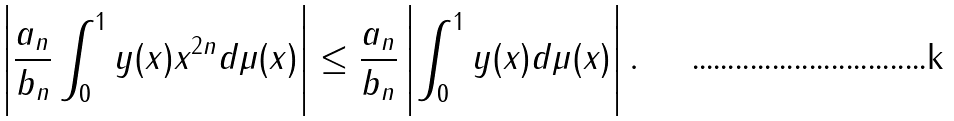<formula> <loc_0><loc_0><loc_500><loc_500>\left | \frac { a _ { n } } { b _ { n } } \int _ { 0 } ^ { 1 } y ( x ) x ^ { 2 n } d \mu ( x ) \right | \leq \frac { a _ { n } } { b _ { n } } \left | \int _ { 0 } ^ { 1 } y ( x ) d \mu ( x ) \right | .</formula> 